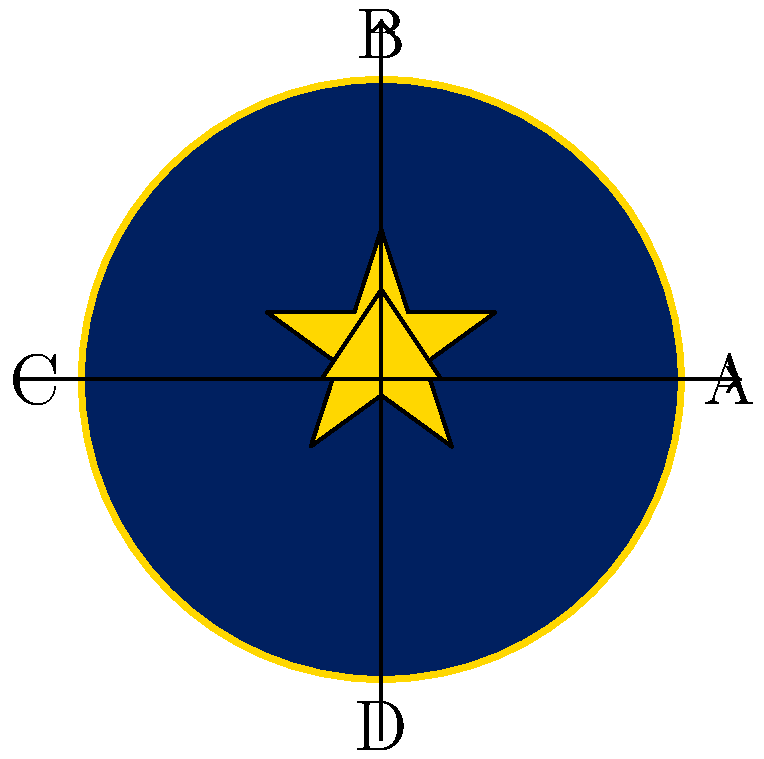Consider the military insignia shown above, which represents a fictional intelligence unit. The insignia consists of a navy blue circular shield with a gold border, a centered gold star, and a stylized gold eagle at the bottom. What is the order of the rotational symmetry group of this insignia, and what are the elements of this group in cycle notation? To determine the rotational symmetry group of the insignia, we need to follow these steps:

1. Identify the center of rotation: The center of the circular shield.

2. Determine the number of distinct rotations that leave the insignia unchanged:
   - 0° rotation (identity): Always present
   - 90° rotation: The insignia changes, so this is not a symmetry
   - 180° rotation: The star and eagle swap positions, leaving the insignia unchanged
   - 270° rotation: The insignia changes, so this is not a symmetry
   - 360° rotation: Same as 0° rotation

3. Count the number of distinct rotations: We have 2 distinct rotations (0° and 180°).

4. The order of the rotational symmetry group is the number of distinct rotations: 2.

5. Express the elements in cycle notation:
   - 0° rotation (identity): $(A)(B)(C)(D)$
   - 180° rotation: $(AC)(BD)$

Therefore, the rotational symmetry group has order 2, and its elements in cycle notation are $\{(A)(B)(C)(D), (AC)(BD)\}$.

This group is isomorphic to the cyclic group $C_2$ or $\mathbb{Z}_2$.
Answer: Order: 2; Elements: $\{(A)(B)(C)(D), (AC)(BD)\}$ 